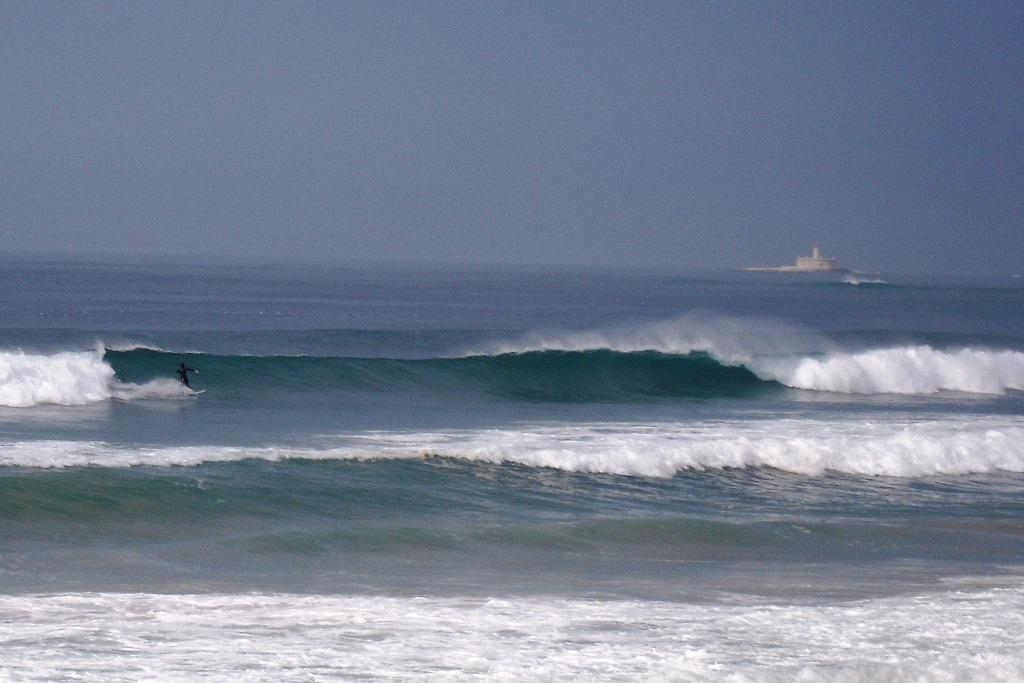What is the primary element in the image? There is water in the image. What activity is the person in the image engaged in? There is a person surfing with a surfboard in the image. What can be seen in the background of the image? There is a building and the sky visible in the background of the image. Where is the uncle with the cannon in the image? There is no uncle or cannon present in the image. What type of match is being played in the image? There is no match being played in the image; it features a person surfing in water. 